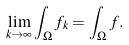Convert formula to latex. <formula><loc_0><loc_0><loc_500><loc_500>\lim _ { k \rightarrow \infty } \int _ { \Omega } { f _ { k } } = \int _ { \Omega } { f } .</formula> 